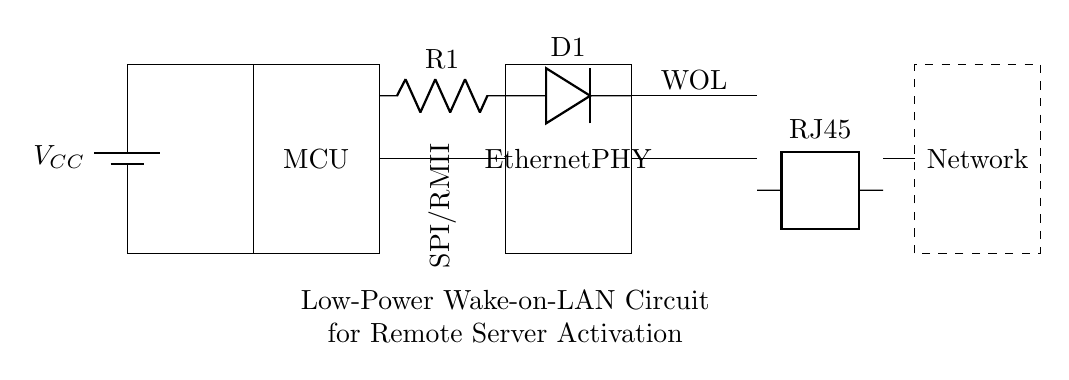What is the primary function of this circuit? The primary function of this circuit is to activate a remote server using the Wake-on-LAN technology. This is indicated by the label “WOL” in the diagram.
Answer: Wake-on-LAN What type of microcontroller is used in this circuit? The diagram does not specify the exact type of microcontroller; it only labels it as "MCU." This implies that a microcontroller unit has been included for control purposes.
Answer: MCU What is the role of the resistor in this circuit? The resistor, labeled as "R1," is likely used to limit the current to the subsequent components, which helps protect them from excessive current and ensures proper operation.
Answer: Current limiting How does this circuit connect to the network? The circuit connects to the network through an RJ45 jack, which is a standard connector used for Ethernet connections, enabling network communication for the Wake-on-LAN functionality.
Answer: RJ45 Which component directly receives power from the battery? The battery is connected to both the microcontroller and ground, indicating that power is supplied straight to the microcontroller for operation.
Answer: Microcontroller What power supply voltage is indicated in this circuit? The diagram includes a label "V_CC," which typically represents the supply voltage; however, the exact voltage value is not specified in the diagram.
Answer: Not specified What is the purpose of the Ethernet PHY in this circuit? The Ethernet Physical Layer Transceiver (PHY) is responsible for handling the physical connection to the network, converting the digital signals from the microcontroller into signals suitable for transmission over the Ethernet network.
Answer: Network interface 